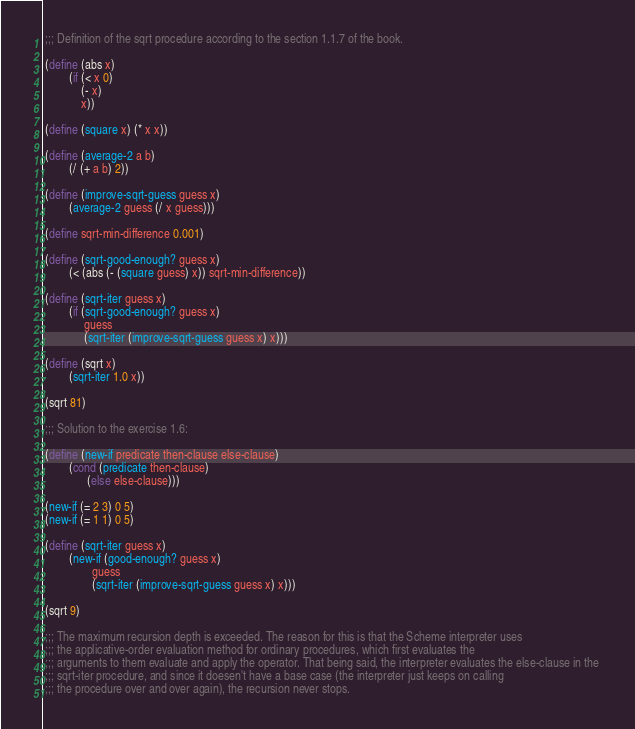<code> <loc_0><loc_0><loc_500><loc_500><_Scheme_>
 ;;; Definition of the sqrt procedure according to the section 1.1.7 of the book.

 (define (abs x)
         (if (< x 0)
             (- x)
             x))

 (define (square x) (* x x))

 (define (average-2 a b)
         (/ (+ a b) 2))

 (define (improve-sqrt-guess guess x)
         (average-2 guess (/ x guess)))

 (define sqrt-min-difference 0.001)

 (define (sqrt-good-enough? guess x)
         (< (abs (- (square guess) x)) sqrt-min-difference))

 (define (sqrt-iter guess x)
         (if (sqrt-good-enough? guess x)
              guess
              (sqrt-iter (improve-sqrt-guess guess x) x)))

 (define (sqrt x)
         (sqrt-iter 1.0 x))

 (sqrt 81)

 ;;; Solution to the exercise 1.6:
 
 (define (new-if predicate then-clause else-clause)
         (cond (predicate then-clause)
               (else else-clause)))

 (new-if (= 2 3) 0 5)
 (new-if (= 1 1) 0 5)

 (define (sqrt-iter guess x)
         (new-if (good-enough? guess x)
                 guess
                 (sqrt-iter (improve-sqrt-guess guess x) x)))

 (sqrt 9)

 ;;; The maximum recursion depth is exceeded. The reason for this is that the Scheme interpreter uses 
 ;;; the applicative-order evaluation method for ordinary procedures, which first evaluates the 
 ;;; arguments to them evaluate and apply the operator. That being said, the interpreter evaluates the else-clause in the 
 ;;; sqrt-iter procedure, and since it doesen't have a base case (the interpreter just keeps on calling 
 ;;; the procedure over and over again), the recursion never stops.

</code> 